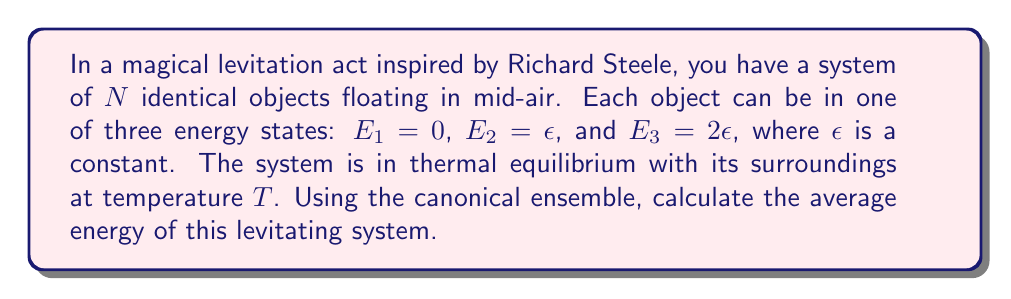Show me your answer to this math problem. To solve this problem using the canonical ensemble, we'll follow these steps:

1) First, we need to write the partition function $Z$ for a single object:

   $$Z = e^{-\beta E_1} + e^{-\beta E_2} + e^{-\beta E_3}$$
   $$Z = 1 + e^{-\beta \epsilon} + e^{-2\beta \epsilon}$$

   where $\beta = \frac{1}{k_B T}$, $k_B$ is Boltzmann's constant.

2) The partition function for the entire system of $N$ independent objects is:

   $$Z_N = Z^N = (1 + e^{-\beta \epsilon} + e^{-2\beta \epsilon})^N$$

3) In the canonical ensemble, the average energy is given by:

   $$\langle E \rangle = -\frac{\partial \ln Z_N}{\partial \beta}$$

4) Let's calculate this:

   $$\ln Z_N = N \ln(1 + e^{-\beta \epsilon} + e^{-2\beta \epsilon})$$

   $$\frac{\partial \ln Z_N}{\partial \beta} = N \frac{-\epsilon e^{-\beta \epsilon} - 2\epsilon e^{-2\beta \epsilon}}{1 + e^{-\beta \epsilon} + e^{-2\beta \epsilon}}$$

5) Therefore, the average energy is:

   $$\langle E \rangle = N\epsilon \frac{e^{-\beta \epsilon} + 2e^{-2\beta \epsilon}}{1 + e^{-\beta \epsilon} + e^{-2\beta \epsilon}}$$

This expression gives the average energy of the system as a function of temperature and the energy level $\epsilon$.
Answer: $$\langle E \rangle = N\epsilon \frac{e^{-\epsilon/(k_B T)} + 2e^{-2\epsilon/(k_B T)}}{1 + e^{-\epsilon/(k_B T)} + e^{-2\epsilon/(k_B T)}}$$ 